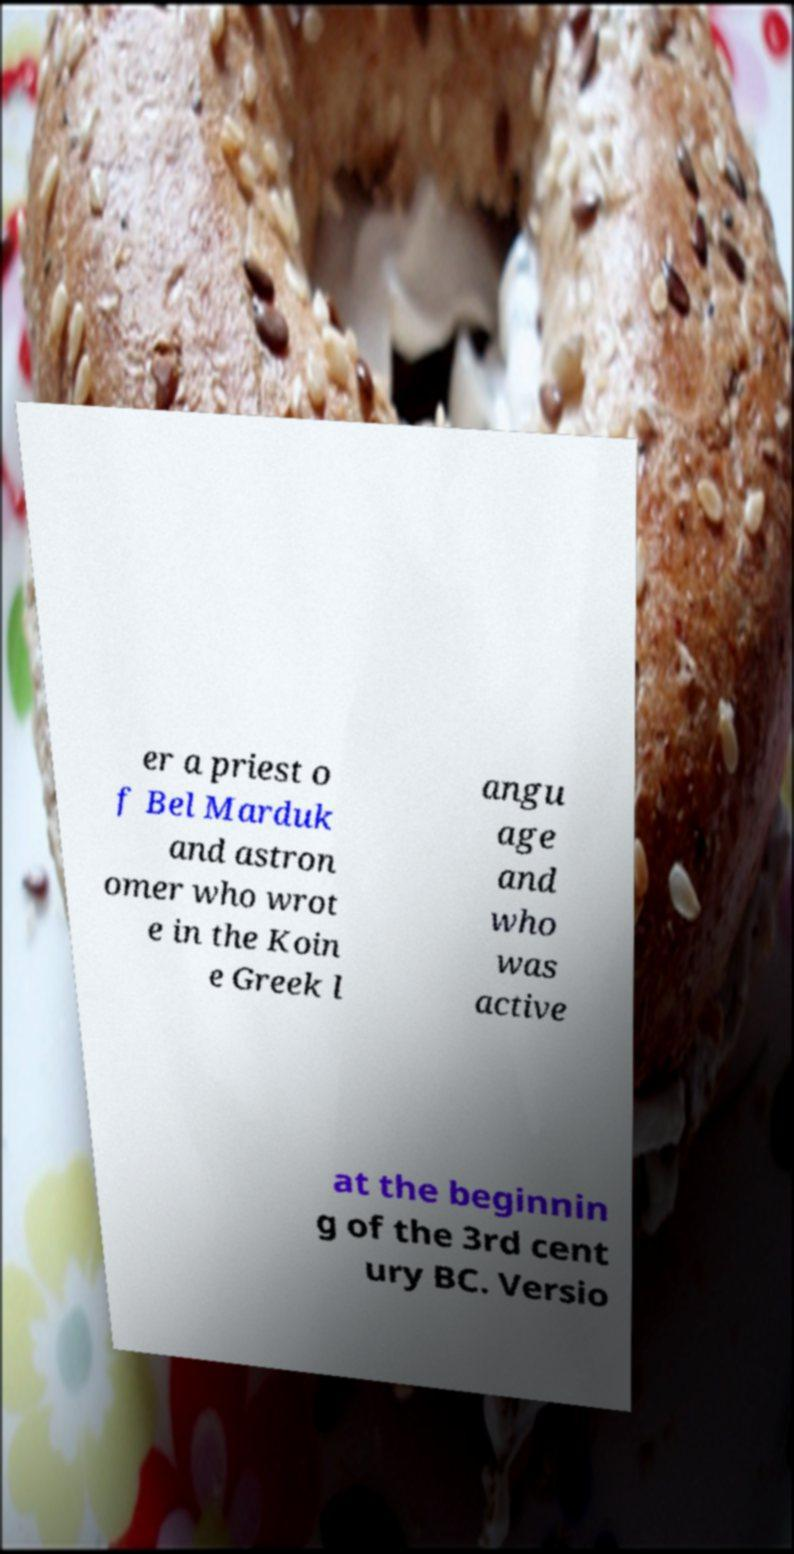Please read and relay the text visible in this image. What does it say? er a priest o f Bel Marduk and astron omer who wrot e in the Koin e Greek l angu age and who was active at the beginnin g of the 3rd cent ury BC. Versio 